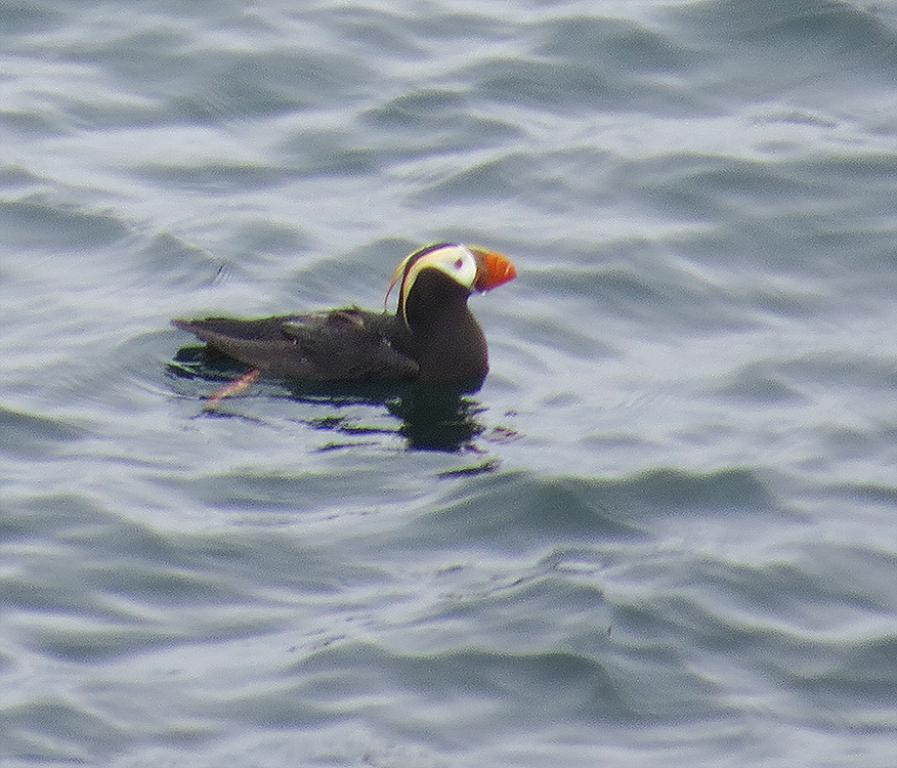What type of animal can be seen in the image? There is a sea bird in the image. Where is the sea bird located? The sea bird is in the water. What is the sea bird using to communicate with other birds in the image? There is no indication in the image that the sea bird is communicating with other birds or using any specific tool for communication. 